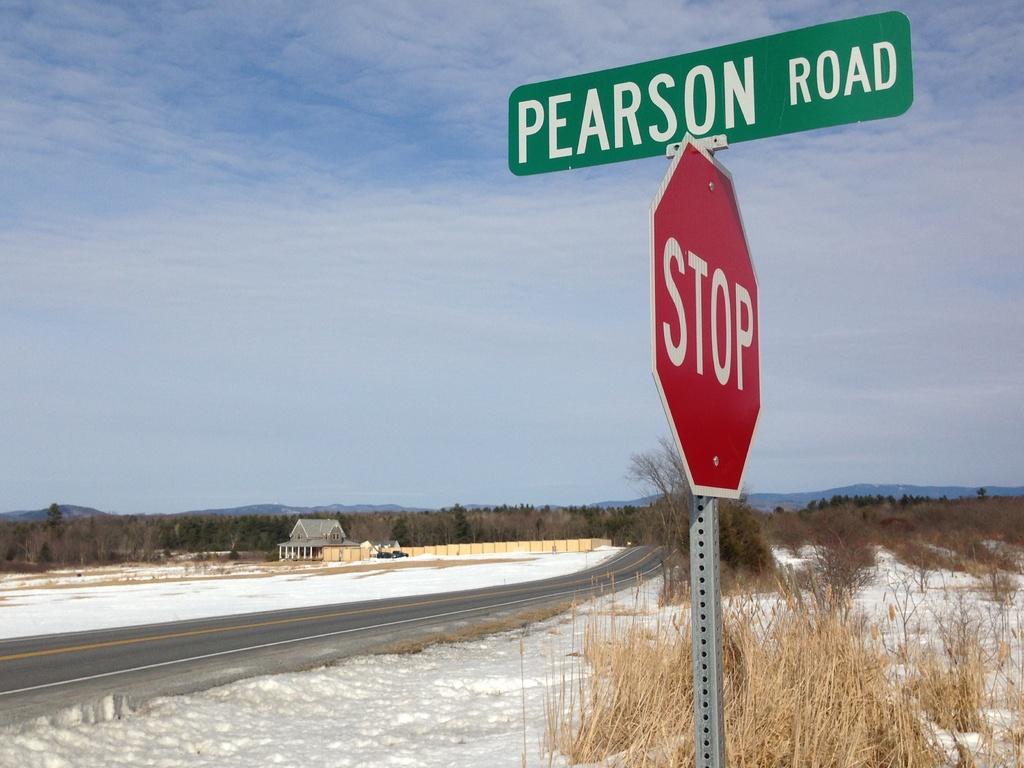What road are you on when you come to a stop?
Ensure brevity in your answer.  Pearson. What type of sign is this?
Offer a terse response. Stop sign. 